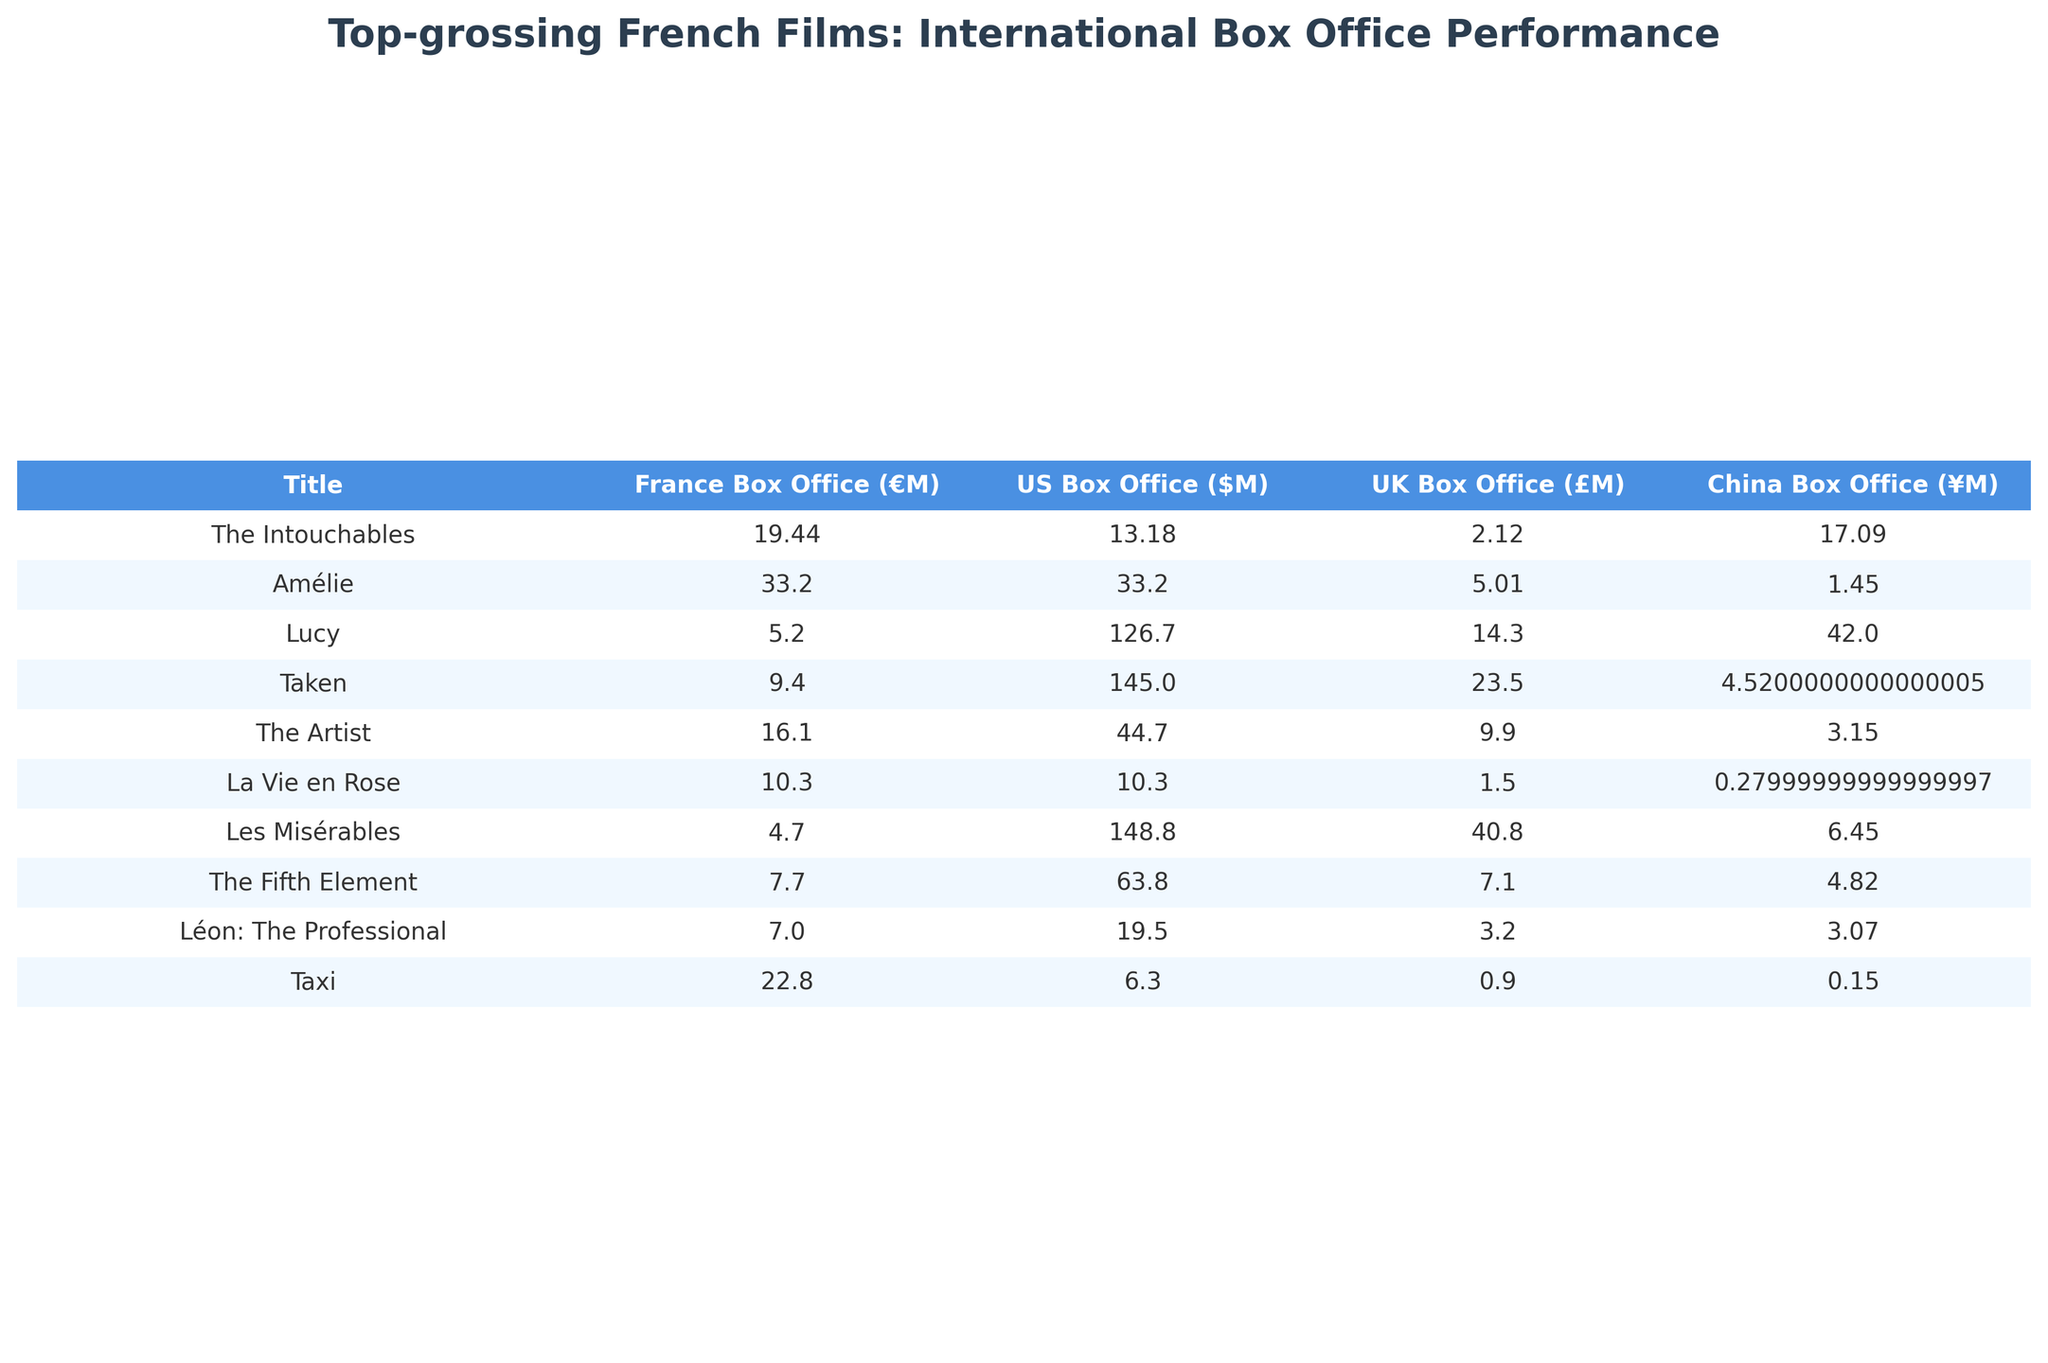What is the highest box office earnings in the US for a French film listed? The table shows that "Lucy" has the highest US Box Office earnings at $126.7 million.
Answer: $126.7 million How much did "Amélie" earn from the UK box office? According to the table, "Amélie" earned £5.01 million from the UK box office.
Answer: £5.01 million Which film had the lowest earnings in France? The table indicates that "Les Misérables" had the lowest earnings in France at €4.7 million.
Answer: €4.7 million What is the total box office earnings from France for "The Intouchables" and "Taxi"? Calculation: €19.44M (The Intouchables) + €22.8M (Taxi) = €42.24M.
Answer: €42.24 million Did "Lucy" earn more in China than in the UK? The table provides the earnings: "Lucy" earned ¥420 million in China, while in the UK it earned £14.3 million. ¥420 million converted is around £53.5 million. Since ¥420 million is greater than £14.3 million, the statement is true.
Answer: Yes Which film had a better cumulative box office performance in the US and France combined? We compare the figures: "Taken" earned $145 million in the US and €9.4 million in France. Converting €9.4 million to dollars (assuming €1 = $1.2 gives approximately $11.28 million), the total is $145M + $11.28M = $156.28M. The total for "Lucy" is $126.7 million (US) + €5.2 million ($6.24 million, approximately) = $132.94 million. Therefore, "Taken" has the better performance.
Answer: Taken What was the difference in box office earnings between "Taxi" in France and "Taxi" in the US? In France, "Taxi" earned €22.8 million and in the US it earned $6.3 million. Converting $6.3 million to euros (assuming €1 = $1.2 gives approximately €5.25 million), the difference is €22.8 million - €5.25 million = €17.55 million.
Answer: €17.55 million Which film had the largest box office collection in China? The table states that "Lucy" has the largest box office collection in China at ¥420 million.
Answer: ¥420 million How does the box office performance of "Les Misérables" in the US compare to that of "La Vie en Rose"? "Les Misérables" earned $148.8 million in the US, while "La Vie en Rose" earned $10.3 million. The difference is significant, showing that "Les Misérables" performed better in the US box office.
Answer: Les Misérables What is the average box office earnings in France for all the listed films? First, sum the French Box Office earnings: 19.44 + 33.2 + 5.2 + 9.4 + 16.1 + 10.3 + 4.7 + 7.7 + 7.0 + 22.8 = 135.1 million. With 10 films, the average is 135.1 million / 10 = 13.51 million.
Answer: €13.51 million Which film earned more in China than in France? "Lucy" earned ¥420 million in China and €5.2 million in France; ¥420 million converts to around €53.5 million, which is higher than €5.2 million. Therefore, "Lucy" is one such film.
Answer: Lucy 